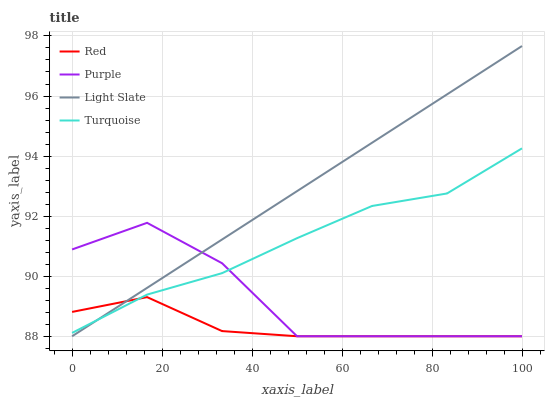Does Red have the minimum area under the curve?
Answer yes or no. Yes. Does Light Slate have the maximum area under the curve?
Answer yes or no. Yes. Does Turquoise have the minimum area under the curve?
Answer yes or no. No. Does Turquoise have the maximum area under the curve?
Answer yes or no. No. Is Light Slate the smoothest?
Answer yes or no. Yes. Is Purple the roughest?
Answer yes or no. Yes. Is Turquoise the smoothest?
Answer yes or no. No. Is Turquoise the roughest?
Answer yes or no. No. Does Turquoise have the lowest value?
Answer yes or no. No. Does Light Slate have the highest value?
Answer yes or no. Yes. Does Turquoise have the highest value?
Answer yes or no. No. 